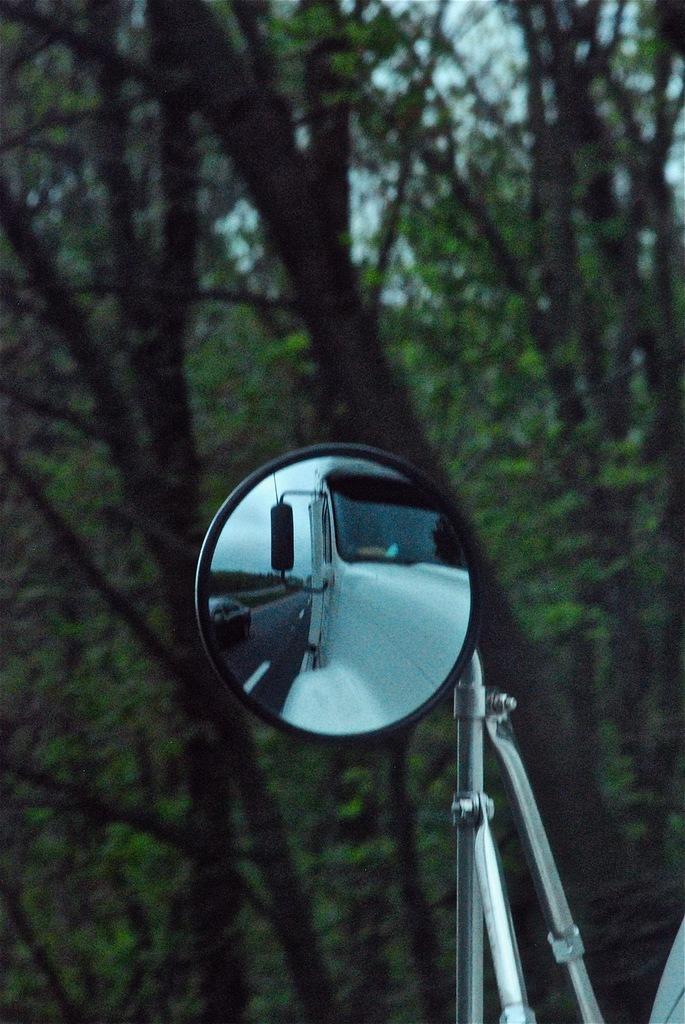Could you give a brief overview of what you see in this image? In this picture we can see vehicle's side mirror, on this side mirror we can see reflection of vehicles on the road. In the background of the image we can see trees and sky. 